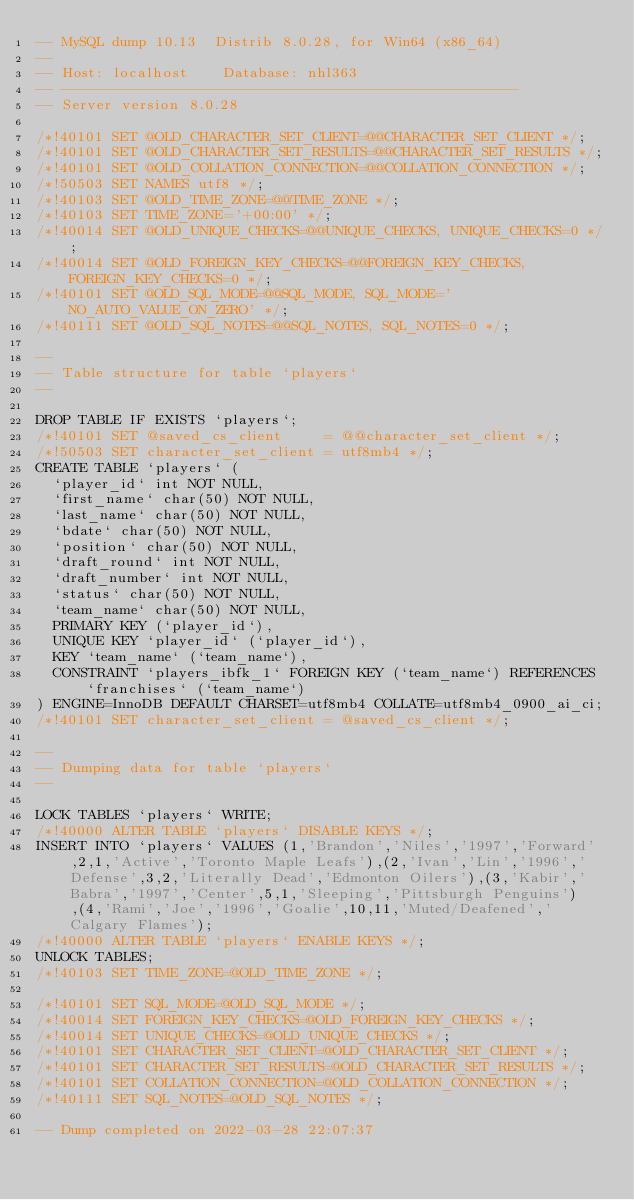Convert code to text. <code><loc_0><loc_0><loc_500><loc_500><_SQL_>-- MySQL dump 10.13  Distrib 8.0.28, for Win64 (x86_64)
--
-- Host: localhost    Database: nhl363
-- ------------------------------------------------------
-- Server version	8.0.28

/*!40101 SET @OLD_CHARACTER_SET_CLIENT=@@CHARACTER_SET_CLIENT */;
/*!40101 SET @OLD_CHARACTER_SET_RESULTS=@@CHARACTER_SET_RESULTS */;
/*!40101 SET @OLD_COLLATION_CONNECTION=@@COLLATION_CONNECTION */;
/*!50503 SET NAMES utf8 */;
/*!40103 SET @OLD_TIME_ZONE=@@TIME_ZONE */;
/*!40103 SET TIME_ZONE='+00:00' */;
/*!40014 SET @OLD_UNIQUE_CHECKS=@@UNIQUE_CHECKS, UNIQUE_CHECKS=0 */;
/*!40014 SET @OLD_FOREIGN_KEY_CHECKS=@@FOREIGN_KEY_CHECKS, FOREIGN_KEY_CHECKS=0 */;
/*!40101 SET @OLD_SQL_MODE=@@SQL_MODE, SQL_MODE='NO_AUTO_VALUE_ON_ZERO' */;
/*!40111 SET @OLD_SQL_NOTES=@@SQL_NOTES, SQL_NOTES=0 */;

--
-- Table structure for table `players`
--

DROP TABLE IF EXISTS `players`;
/*!40101 SET @saved_cs_client     = @@character_set_client */;
/*!50503 SET character_set_client = utf8mb4 */;
CREATE TABLE `players` (
  `player_id` int NOT NULL,
  `first_name` char(50) NOT NULL,
  `last_name` char(50) NOT NULL,
  `bdate` char(50) NOT NULL,
  `position` char(50) NOT NULL,
  `draft_round` int NOT NULL,
  `draft_number` int NOT NULL,
  `status` char(50) NOT NULL,
  `team_name` char(50) NOT NULL,
  PRIMARY KEY (`player_id`),
  UNIQUE KEY `player_id` (`player_id`),
  KEY `team_name` (`team_name`),
  CONSTRAINT `players_ibfk_1` FOREIGN KEY (`team_name`) REFERENCES `franchises` (`team_name`)
) ENGINE=InnoDB DEFAULT CHARSET=utf8mb4 COLLATE=utf8mb4_0900_ai_ci;
/*!40101 SET character_set_client = @saved_cs_client */;

--
-- Dumping data for table `players`
--

LOCK TABLES `players` WRITE;
/*!40000 ALTER TABLE `players` DISABLE KEYS */;
INSERT INTO `players` VALUES (1,'Brandon','Niles','1997','Forward',2,1,'Active','Toronto Maple Leafs'),(2,'Ivan','Lin','1996','Defense',3,2,'Literally Dead','Edmonton Oilers'),(3,'Kabir','Babra','1997','Center',5,1,'Sleeping','Pittsburgh Penguins'),(4,'Rami','Joe','1996','Goalie',10,11,'Muted/Deafened','Calgary Flames');
/*!40000 ALTER TABLE `players` ENABLE KEYS */;
UNLOCK TABLES;
/*!40103 SET TIME_ZONE=@OLD_TIME_ZONE */;

/*!40101 SET SQL_MODE=@OLD_SQL_MODE */;
/*!40014 SET FOREIGN_KEY_CHECKS=@OLD_FOREIGN_KEY_CHECKS */;
/*!40014 SET UNIQUE_CHECKS=@OLD_UNIQUE_CHECKS */;
/*!40101 SET CHARACTER_SET_CLIENT=@OLD_CHARACTER_SET_CLIENT */;
/*!40101 SET CHARACTER_SET_RESULTS=@OLD_CHARACTER_SET_RESULTS */;
/*!40101 SET COLLATION_CONNECTION=@OLD_COLLATION_CONNECTION */;
/*!40111 SET SQL_NOTES=@OLD_SQL_NOTES */;

-- Dump completed on 2022-03-28 22:07:37
</code> 